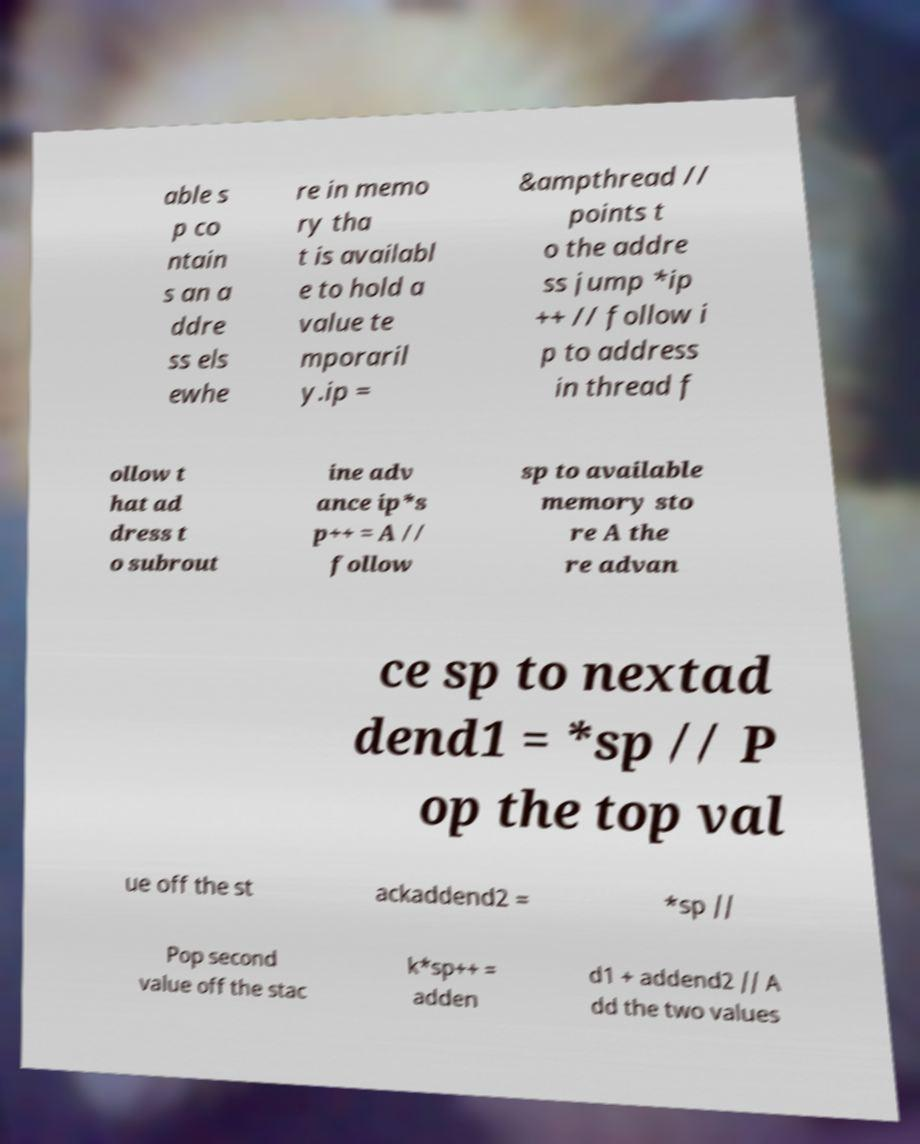Could you extract and type out the text from this image? able s p co ntain s an a ddre ss els ewhe re in memo ry tha t is availabl e to hold a value te mporaril y.ip = &ampthread // points t o the addre ss jump *ip ++ // follow i p to address in thread f ollow t hat ad dress t o subrout ine adv ance ip*s p++ = A // follow sp to available memory sto re A the re advan ce sp to nextad dend1 = *sp // P op the top val ue off the st ackaddend2 = *sp // Pop second value off the stac k*sp++ = adden d1 + addend2 // A dd the two values 